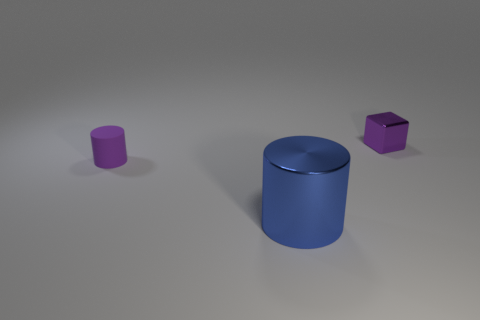What color is the thing that is in front of the purple object that is in front of the small purple metal cube?
Keep it short and to the point. Blue. Is the shiny block the same size as the blue shiny object?
Keep it short and to the point. No. Do the purple thing on the left side of the cube and the tiny object to the right of the blue metallic object have the same material?
Your response must be concise. No. There is a tiny thing left of the metal thing in front of the cylinder left of the large blue metallic cylinder; what is its shape?
Your response must be concise. Cylinder. Are there more tiny matte blocks than things?
Provide a succinct answer. No. Are there any yellow metallic objects?
Your answer should be compact. No. How many objects are objects to the right of the small purple cylinder or purple things to the right of the large metal cylinder?
Your response must be concise. 2. Do the rubber cylinder and the metallic cylinder have the same color?
Your response must be concise. No. Is the number of purple metal blocks less than the number of big brown cylinders?
Give a very brief answer. No. There is a purple cylinder; are there any large metal things behind it?
Your response must be concise. No. 